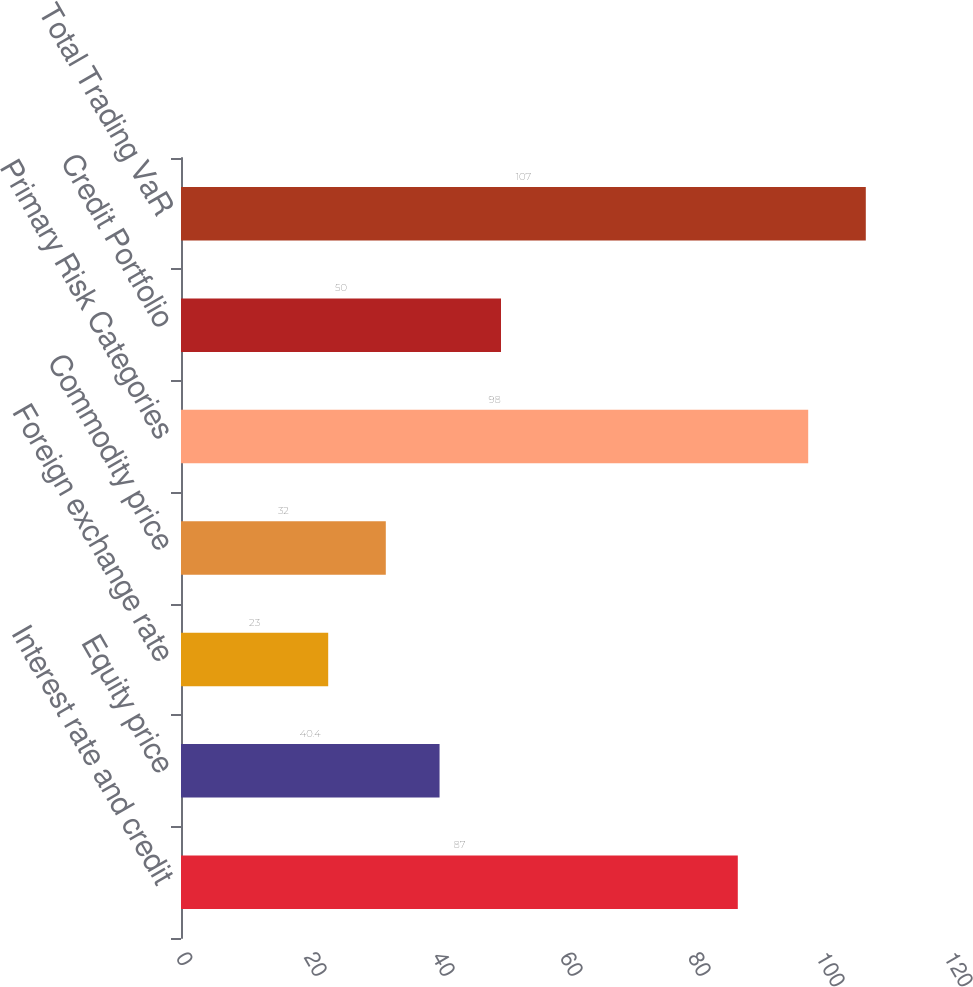<chart> <loc_0><loc_0><loc_500><loc_500><bar_chart><fcel>Interest rate and credit<fcel>Equity price<fcel>Foreign exchange rate<fcel>Commodity price<fcel>Primary Risk Categories<fcel>Credit Portfolio<fcel>Total Trading VaR<nl><fcel>87<fcel>40.4<fcel>23<fcel>32<fcel>98<fcel>50<fcel>107<nl></chart> 